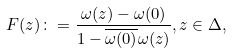Convert formula to latex. <formula><loc_0><loc_0><loc_500><loc_500>F ( z ) \colon = \frac { \omega ( z ) - \omega ( 0 ) } { 1 - \overline { \omega ( 0 ) } \omega ( z ) } , z \in \Delta ,</formula> 